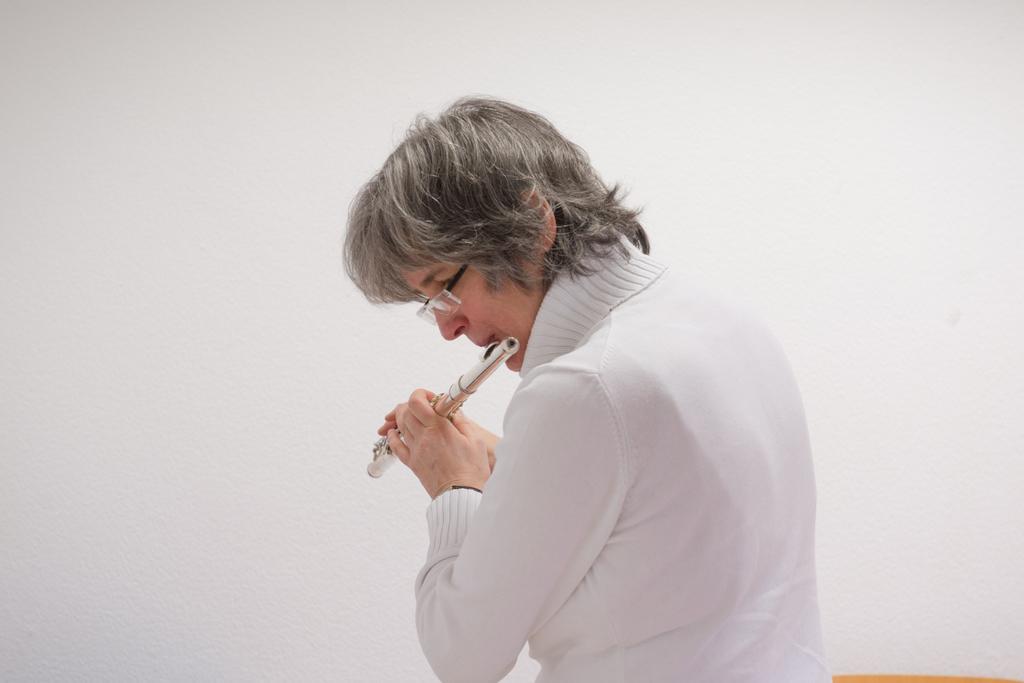In one or two sentences, can you explain what this image depicts? In this image I can see a woman in white dress playing a musical instrument. I can also see she is wearing a specs. 